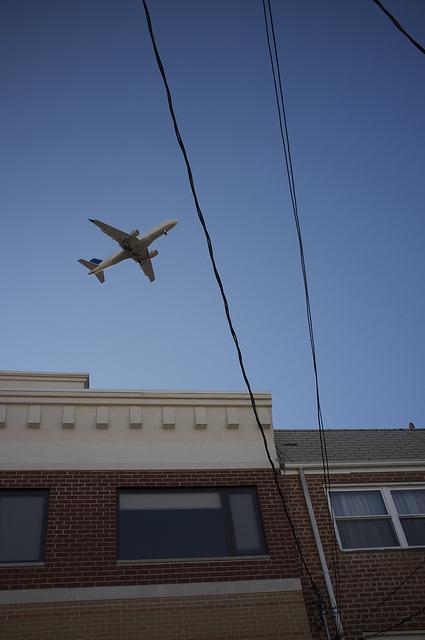Is this plane inside?
Keep it brief. No. How high is the plane?
Concise answer only. Low. What is the man riding?
Keep it brief. Plane. What is in the sky?
Answer briefly. Plane. 